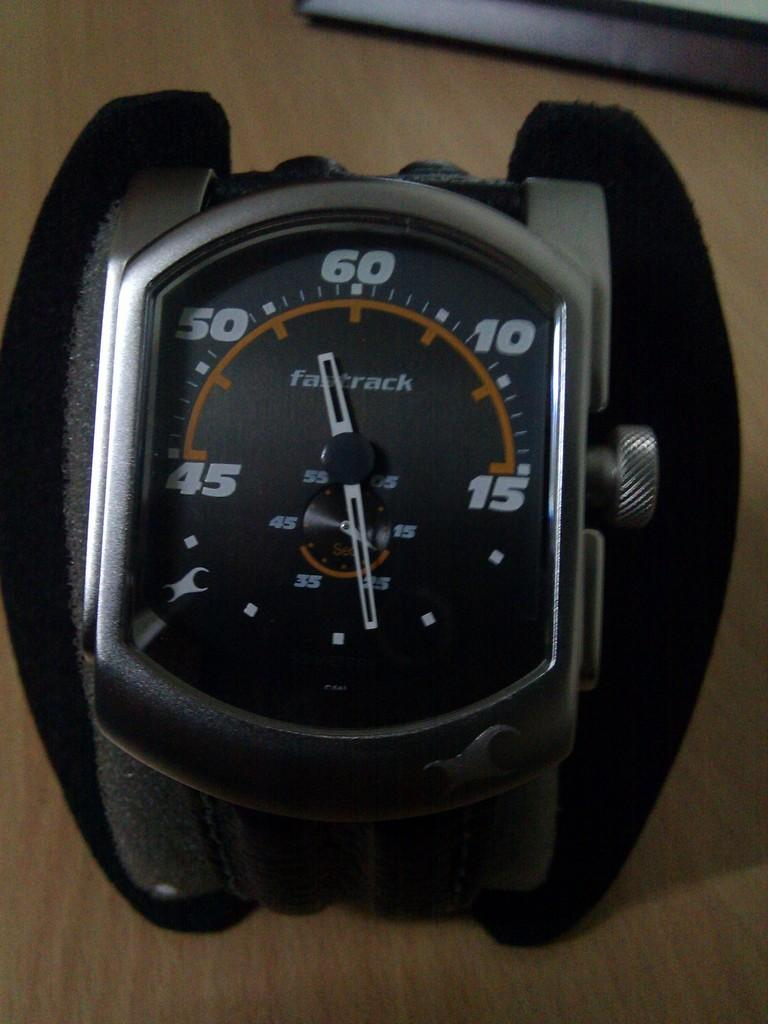<image>
Provide a brief description of the given image. a watch with the big hand pointing to the number 58 